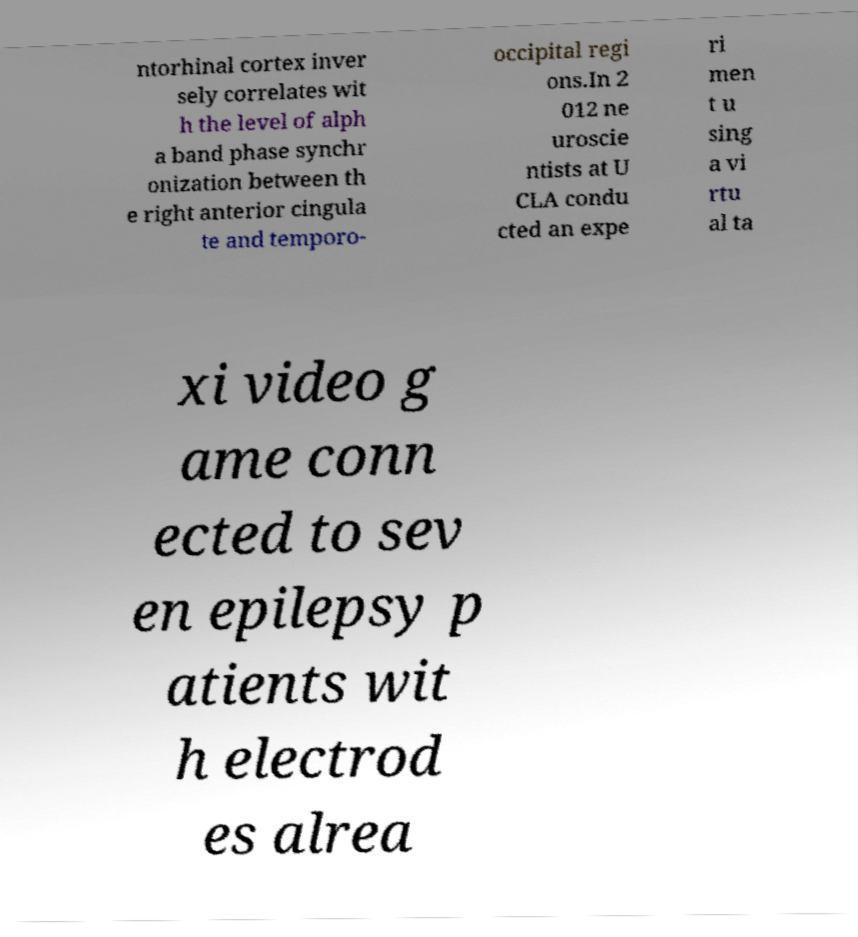Could you extract and type out the text from this image? ntorhinal cortex inver sely correlates wit h the level of alph a band phase synchr onization between th e right anterior cingula te and temporo- occipital regi ons.In 2 012 ne uroscie ntists at U CLA condu cted an expe ri men t u sing a vi rtu al ta xi video g ame conn ected to sev en epilepsy p atients wit h electrod es alrea 